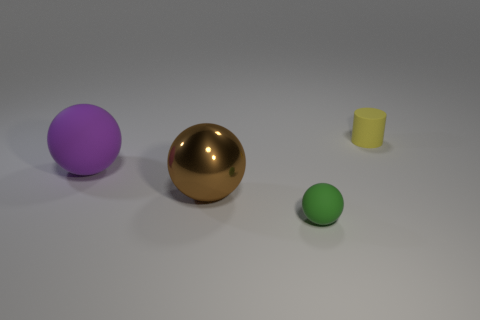Are there any brown shiny objects of the same shape as the purple matte object?
Your response must be concise. Yes. Are there the same number of large purple rubber spheres right of the big brown ball and big things?
Your answer should be very brief. No. What is the material of the small object on the left side of the small matte thing that is right of the green ball?
Provide a short and direct response. Rubber. What shape is the purple matte thing?
Give a very brief answer. Sphere. Are there the same number of tiny green objects that are behind the small cylinder and things that are on the left side of the tiny rubber sphere?
Make the answer very short. No. Are there more large balls on the left side of the large brown ball than large blue metallic cubes?
Make the answer very short. Yes. What shape is the green thing that is the same material as the purple thing?
Make the answer very short. Sphere. There is a rubber ball left of the brown ball; is it the same size as the tiny rubber cylinder?
Provide a short and direct response. No. The small thing that is on the left side of the tiny object that is behind the green sphere is what shape?
Your answer should be very brief. Sphere. How big is the matte ball that is on the left side of the large thing in front of the purple rubber thing?
Provide a short and direct response. Large. 